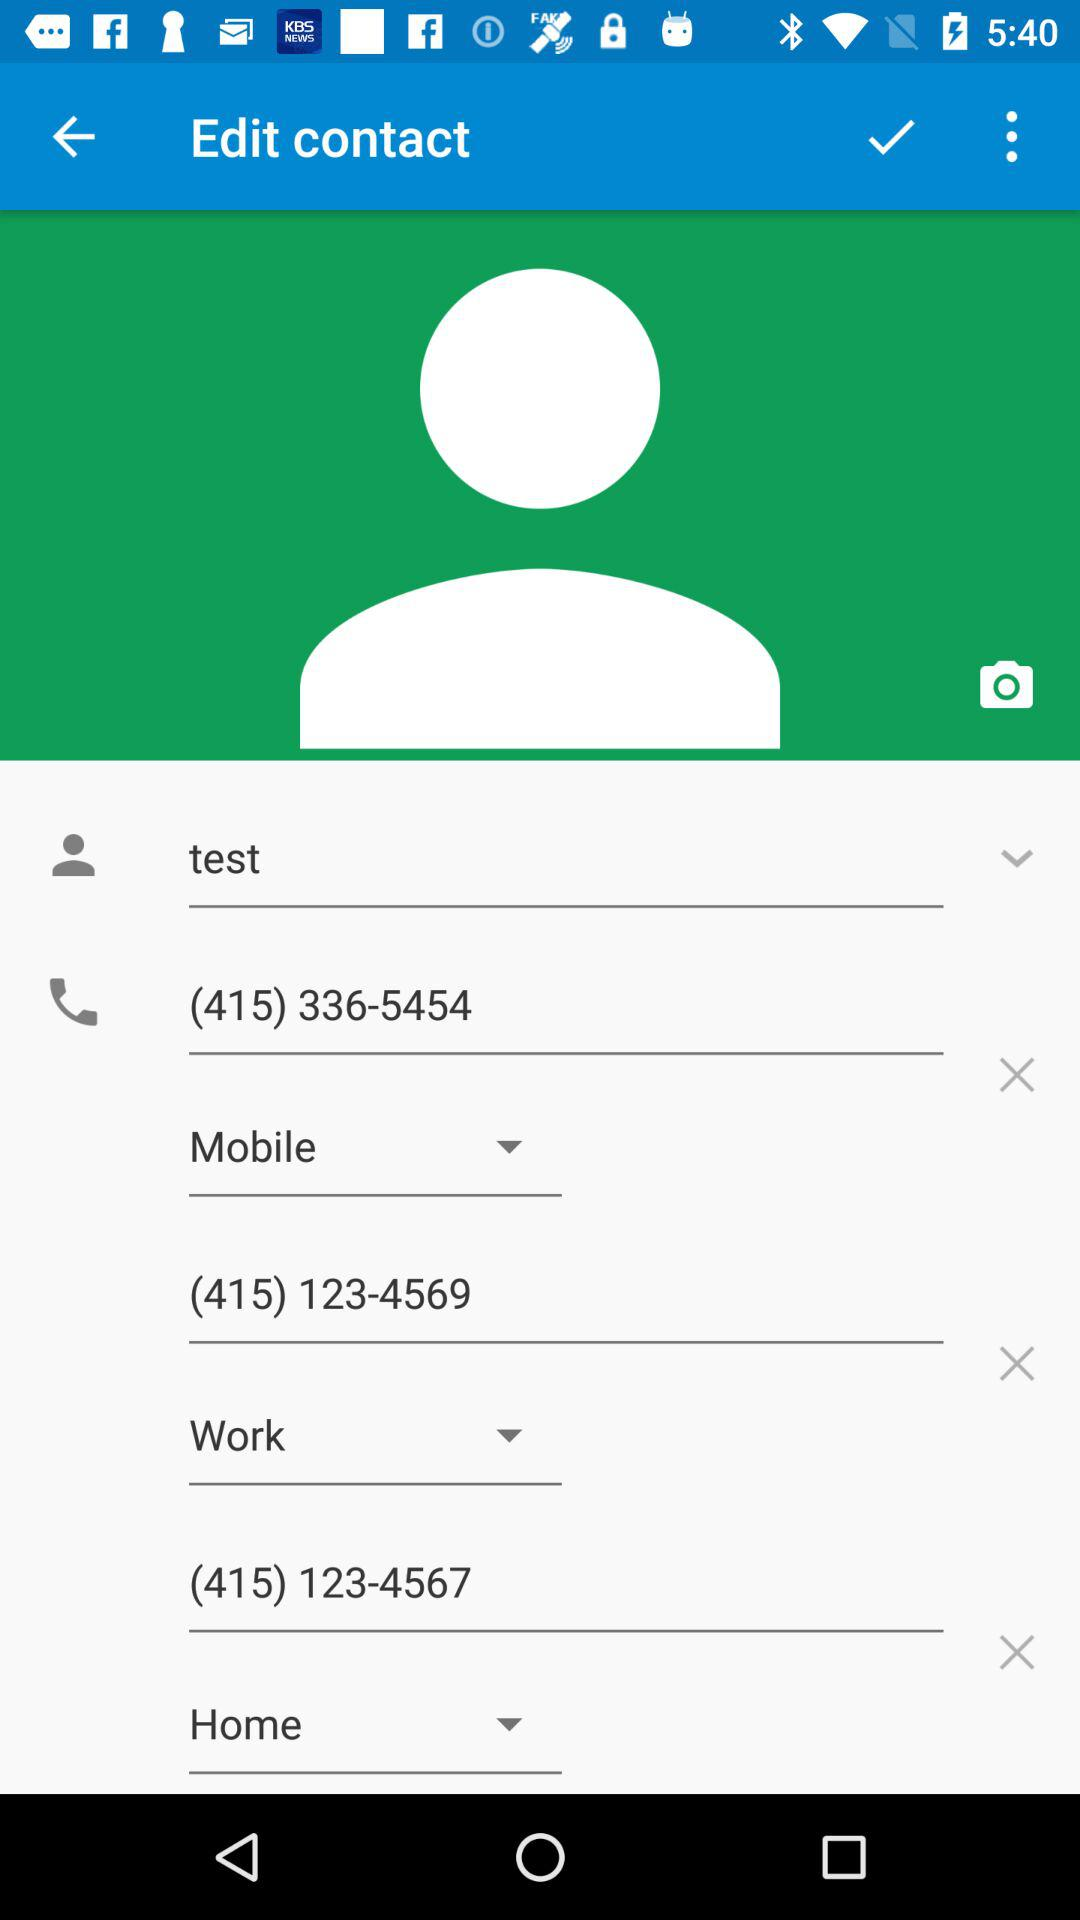How many of the phone numbers are work numbers?
Answer the question using a single word or phrase. 1 